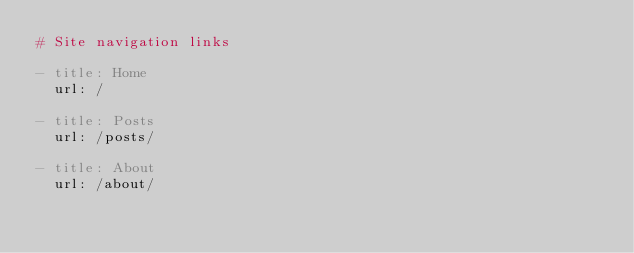Convert code to text. <code><loc_0><loc_0><loc_500><loc_500><_YAML_># Site navigation links

- title: Home
  url: /

- title: Posts
  url: /posts/

- title: About
  url: /about/
</code> 